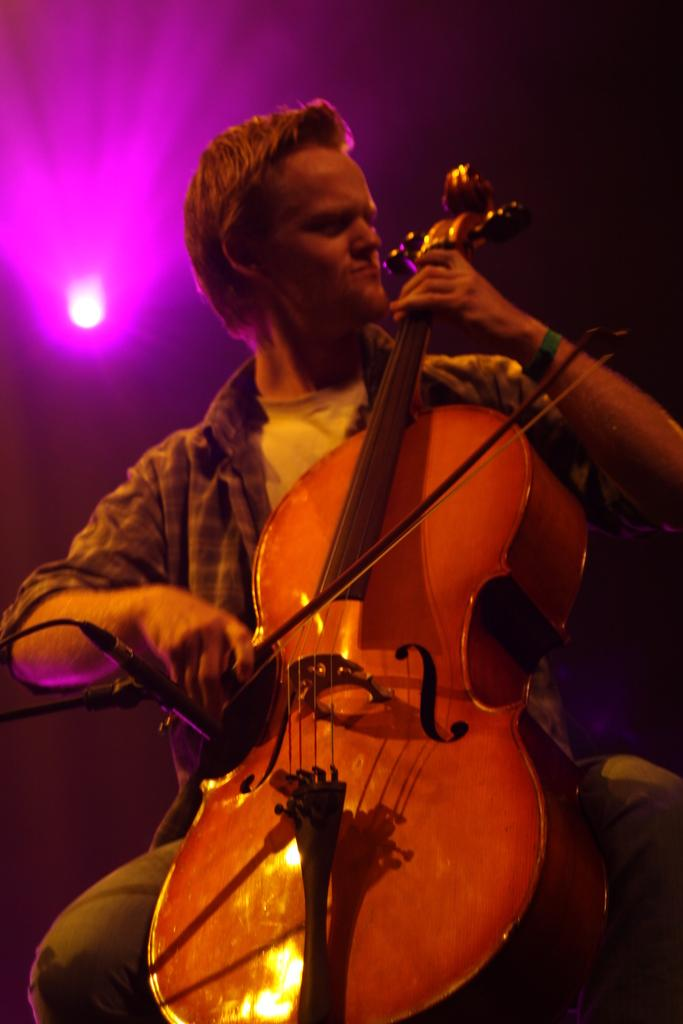Who is the main subject in the image? There is a man in the image. What is the man doing in the image? The man is sitting on a table and playing a violin. Can you describe the lighting in the image? There is light focusing on the back side of the image. What type of pancake is the man flipping in the image? There is no pancake present in the image; the man is playing a violin. Can you see any worms crawling on the table in the image? There are no worms visible in the image; the man is playing a violin while sitting on a table. 